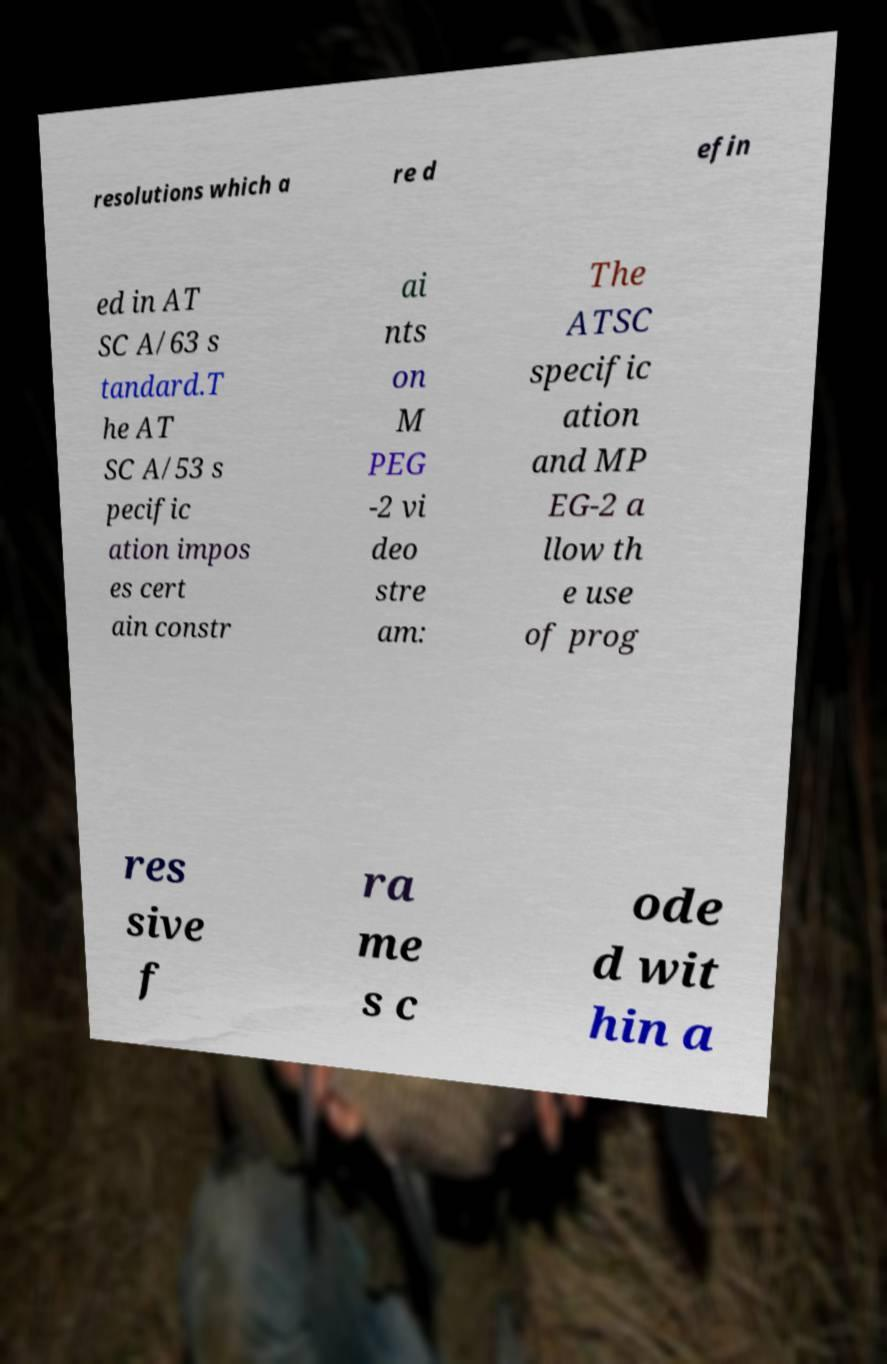What messages or text are displayed in this image? I need them in a readable, typed format. resolutions which a re d efin ed in AT SC A/63 s tandard.T he AT SC A/53 s pecific ation impos es cert ain constr ai nts on M PEG -2 vi deo stre am: The ATSC specific ation and MP EG-2 a llow th e use of prog res sive f ra me s c ode d wit hin a 